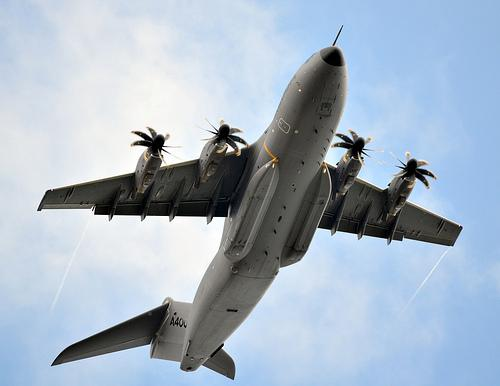Describe the core subject in the image and any visible actions taking place. A Hercules military plane is the core subject, seen flying with its propellers in motion and emitting a jet stream. Briefly explain the main object in the picture and what is happening. The main object is a Hercules military plane in the air, with its propellers spinning and jet stream present. What is the dominant subject in the image and what action is happening? The dominant subject is a military plane in flight, with its propellers spinning and jet stream visible. Mention the primary focus of the image and its most important features. The image is focused on a Hercules military plane, showcasing its four prop engines, wings, and rudders. In short, describe the primary subject of the image and its distinct features. The image displays a flying military Hercules plane, equipped with four prop engines, wings, and a unique orange stripe. State the key subject in the image and any significant actions occurring. The key subject is a military Hercules plane, flying with its propellers turning and jet stream visible. Provide a brief description of the central object in the image. A military plane called Hercules is flying in the sky with four propellers spinning on its wings. Identify the main object in the image and describe its key attributes. The main object is an airborne Hercules military plane, characterized by its four prop engines, wings, and orange highlights. Tell what the main focus of the image is and what key event is taking place. The main focus is a flying Hercules military plane, with its propellers in motion and a visible jet stream. Describe the prominent object in the image and any notable activities happening. A military Hercules plane is prominently featured, flying with its propellers rotating and a jet stream showing. 